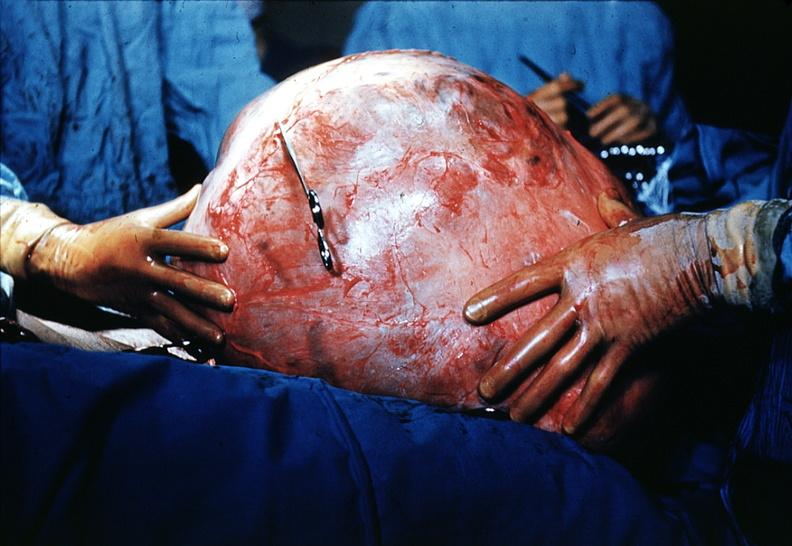does this image show massive lesion taken at surgery size of basketball very good?
Answer the question using a single word or phrase. Yes 